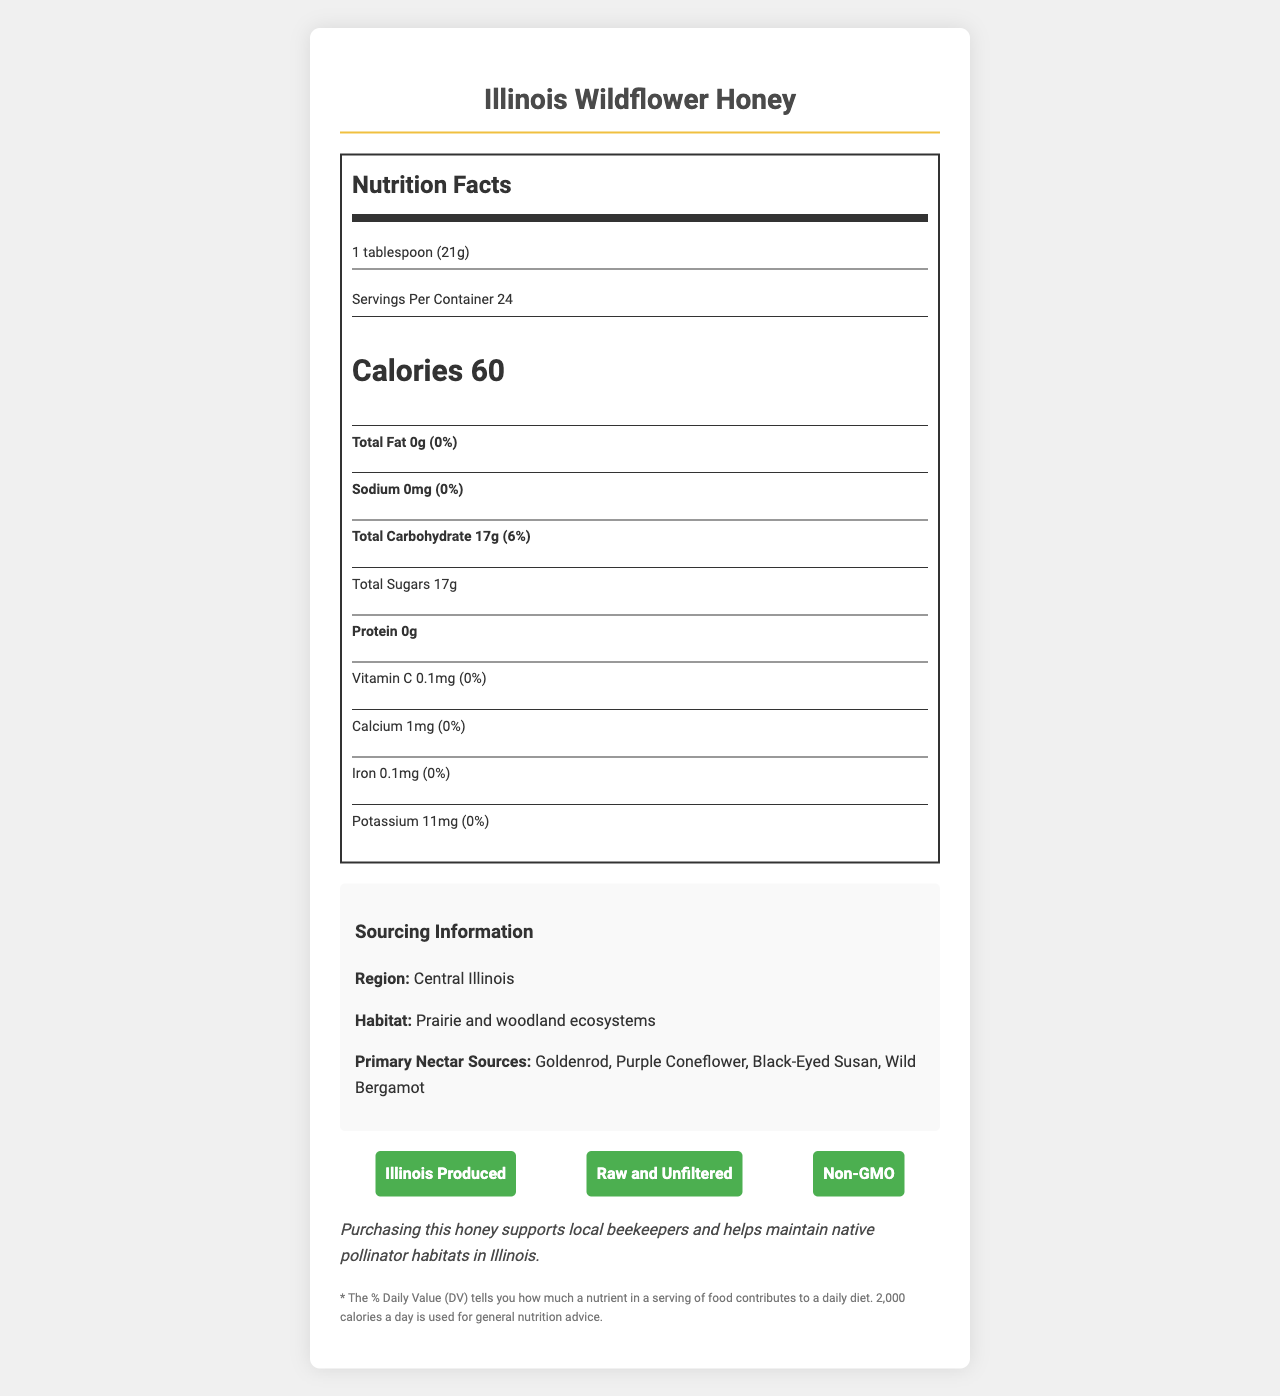what is the serving size for Illinois Wildflower Honey? The serving size is listed as "1 tablespoon (21g)" under the "Nutrition Facts" section.
Answer: 1 tablespoon (21g) how many calories are in one serving? Under the "Nutrition Facts" section, it states "Calories 60".
Answer: 60 what is the total carbohydrate content per serving? The "Total Carbohydrate" content is noted as "17g" in the nutrition label.
Answer: 17g list three antioxidants mentioned in the nutrition facts. The antioxidants listed under the "antioxidants" section are "Flavonoids", "Phenolic acids", and "Ascorbic acid".
Answer: Flavonoids, Phenolic acids, Ascorbic acid name one of the primary nectar sources for Illinois Wildflower Honey. One primary nectar source listed under "Primary Nectar Sources" is "Goldenrod".
Answer: Goldenrod how many servings are there per container? The "Servings Per Container" is listed as "24" in the "Nutrition Facts" section.
Answer: 24 does this honey contain any protein? The amount of protein is listed as "0g" in the nutrition label.
Answer: No which region is the honey sourced from? A. Northern Illinois B. Central Illinois C. Southern Illinois D. Eastern Illinois Under "Sourcing Information", the region is noted as "Central Illinois".
Answer: B. Central Illinois what certifications does this honey have? A. Raw and Unfiltered B. Organic C. Non-GMO D. Local D. All of the above E. A, C, and D only The certifications listed are "Illinois Produced", "Raw and Unfiltered", and "Non-GMO".
Answer: E. A, C, and D only is this product non-GMO certified? One of the certifications listed is "Non-GMO".
Answer: Yes summarize the main idea of the Illinois Wildflower Honey document. The document provides detailed nutrition facts, sourcing information, certifications, and notes the environmental benefits of purchasing this honey.
Answer: Illinois Wildflower Honey is a locally produced raw and unfiltered honey with natural antioxidants and trace minerals, supporting local beekeepers and native pollinator habitats. how much Iron is present per serving according to the document? The "Iron" content per serving is shown as "0.1mg" under the vitamins and minerals list.
Answer: 0.1mg what role does purchasing Illinois Wildflower Honey play in conservation efforts? The "conservation note" states that purchasing this honey supports local beekeepers and helps maintain native pollinator habitats in Illinois.
Answer: Supports local beekeepers and helps maintain native pollinator habitats in Illinois. where can I buy Illinois Wildflower Honey locally? The document doesn’t provide specific information on where to purchase the honey locally.
Answer: Cannot be determined 